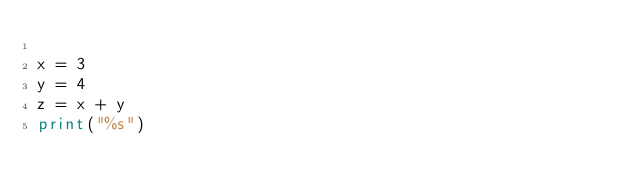Convert code to text. <code><loc_0><loc_0><loc_500><loc_500><_Python_>
x = 3
y = 4
z = x + y
print("%s")
</code> 